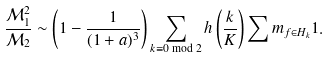Convert formula to latex. <formula><loc_0><loc_0><loc_500><loc_500>\frac { { \mathcal { M } } _ { 1 } ^ { 2 } } { { \mathcal { M } } _ { 2 } } \sim \left ( 1 - \frac { 1 } { ( 1 + a ) ^ { 3 } } \right ) \sum _ { k \equiv 0 \bmod 2 } h \left ( \frac { k } { K } \right ) \sum m _ { f \in H _ { k } } 1 .</formula> 